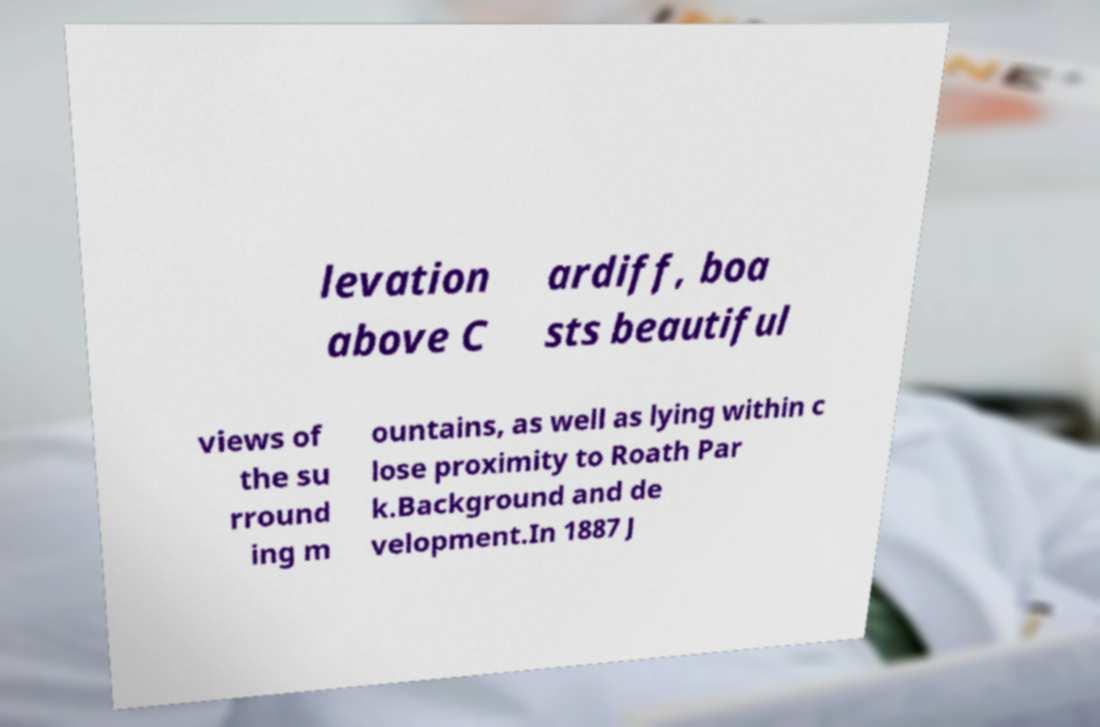Could you assist in decoding the text presented in this image and type it out clearly? levation above C ardiff, boa sts beautiful views of the su rround ing m ountains, as well as lying within c lose proximity to Roath Par k.Background and de velopment.In 1887 J 